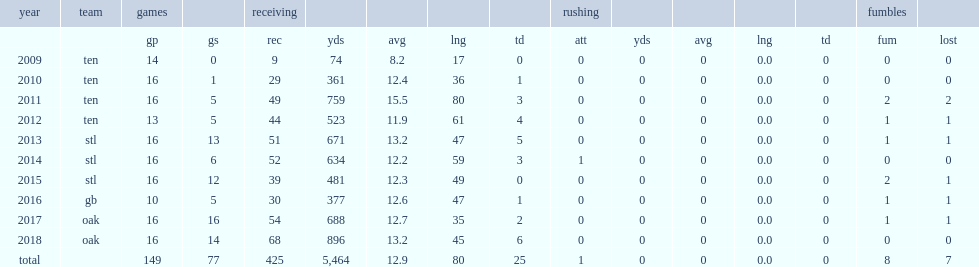When did coo make 44 receptions for 523 yards and four touchdown receptions in 13 games and five starts? 2012.0. 